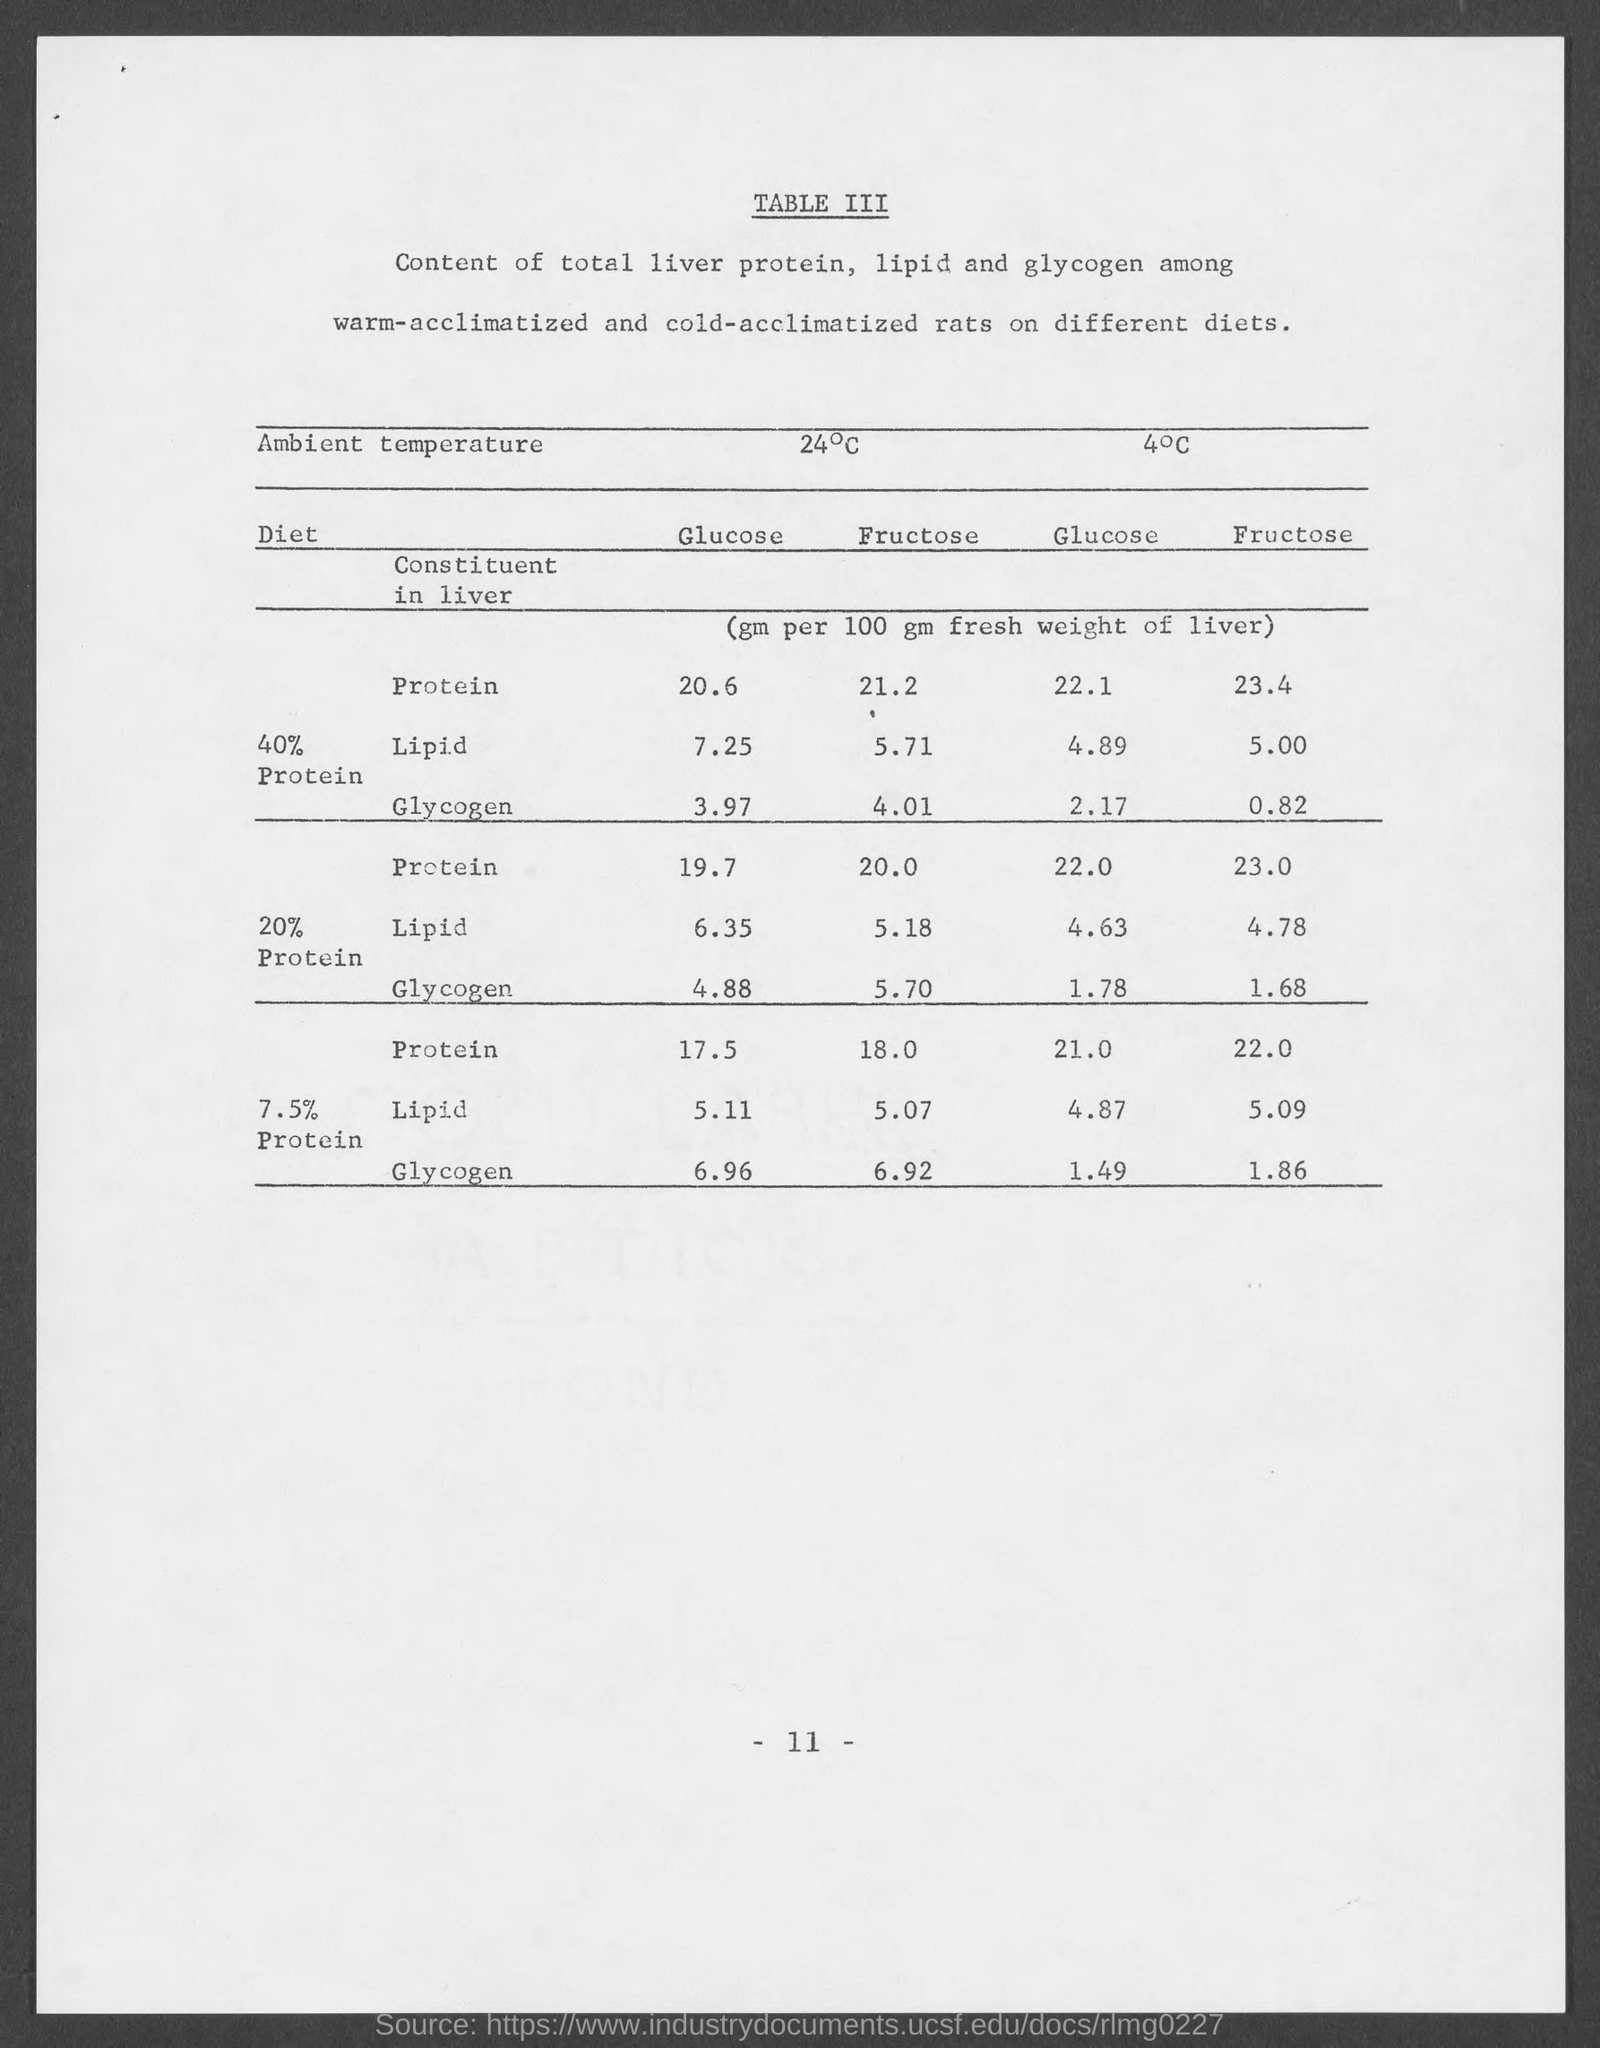Mention a couple of crucial points in this snapshot. The page number at the bottom of the page is 11 